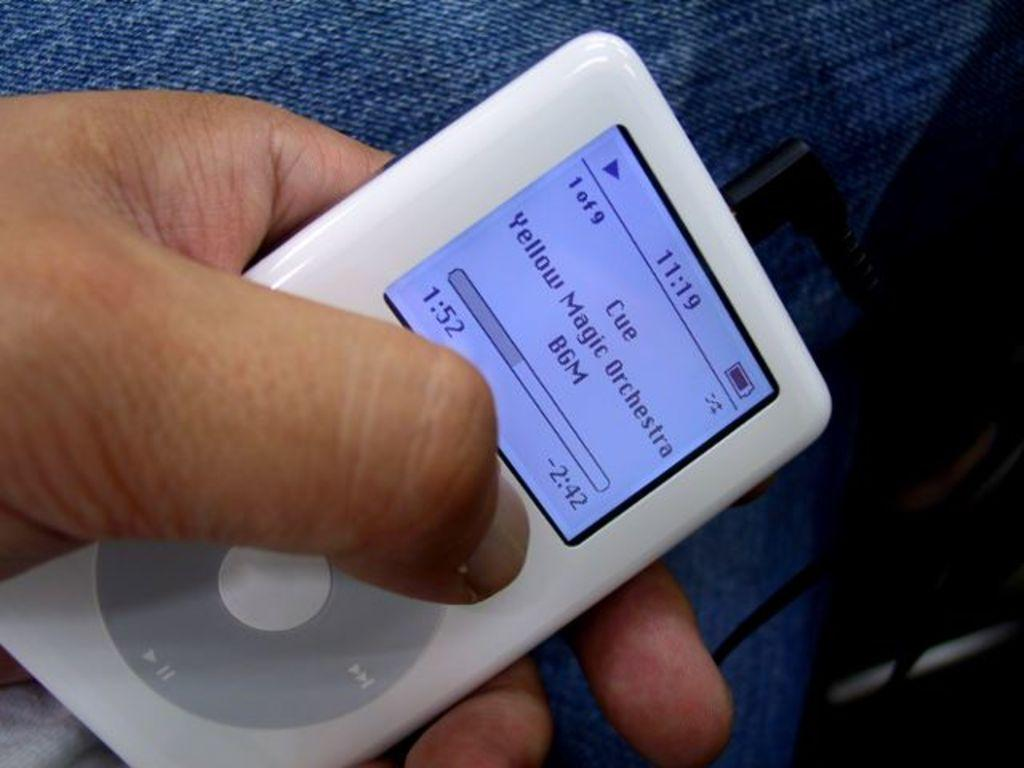What electronic device is visible in the image? There is an iPod in the image. How is the iPod being held in the image? The iPod is being held in someone's hand. What type of maid is responsible for the iPod's digestion in the image? There is no maid or digestion mentioned in the image; it simply shows an iPod being held in someone's hand. 